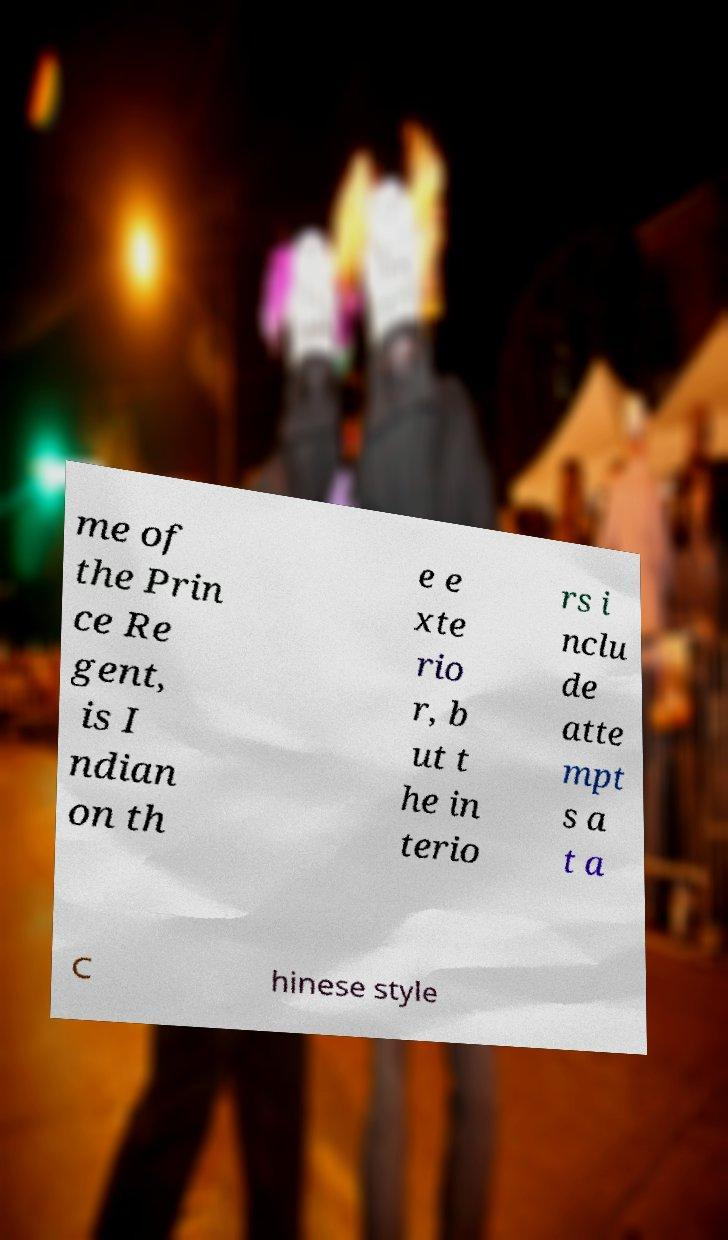Please read and relay the text visible in this image. What does it say? me of the Prin ce Re gent, is I ndian on th e e xte rio r, b ut t he in terio rs i nclu de atte mpt s a t a C hinese style 